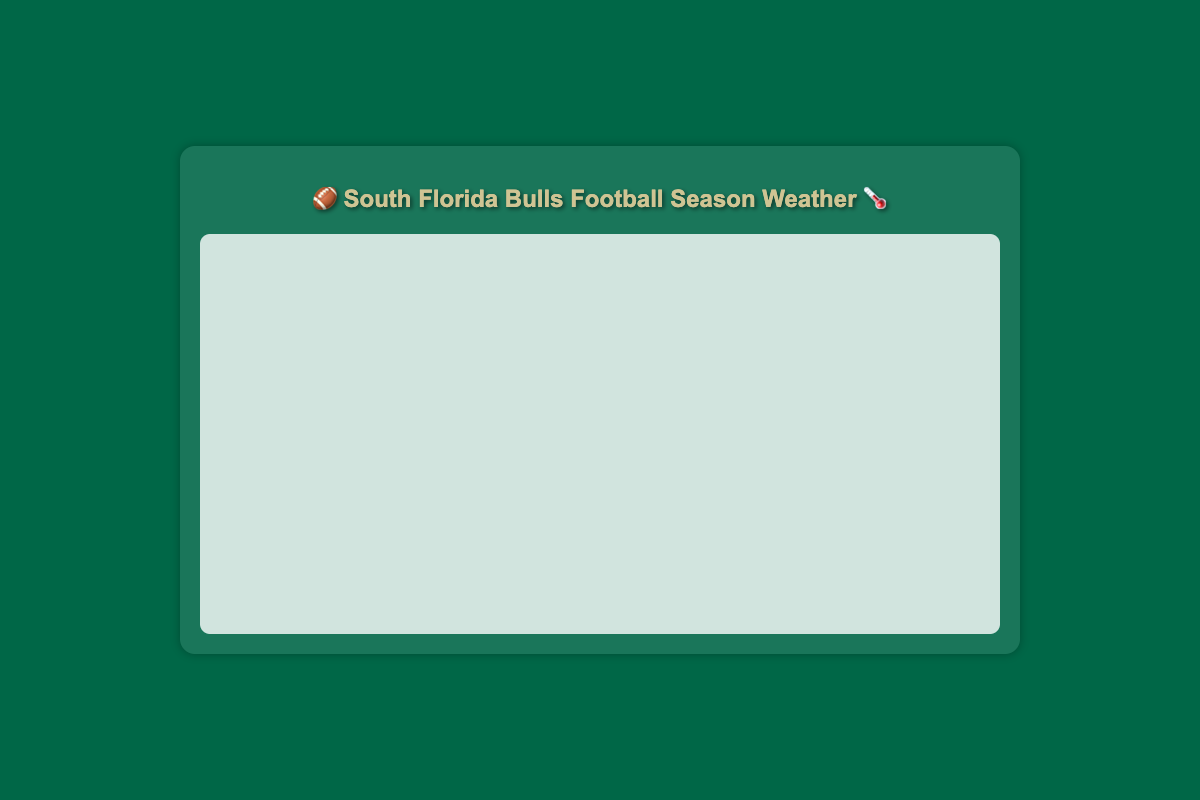What is the highest recorded temperature and on which date did it occur? The highest recorded temperature can be found by examining the "High Temperature" line on the chart and identifying the peak point. The corresponding date will be located on the x-axis vertically aligned with this peak.
Answer: 91°F on 2023-09-10 and 2023-09-24 How does the precipitation on September 10 compare to September 7? To compare the precipitation, check the "Precipitation (inches)" line on the relevant dates. September 10 shows a higher peak than September 7, indicating more precipitation.
Answer: Higher on September 10 What was the average high temperature from September 1 to September 10? To calculate this, sum the high temperatures from September 1 to September 10 and divide by the number of days. The sum is 88 + 89 + 87 + 90 + 89 + 88 + 87 + 86 + 89 + 91 = 884. The average is 884 / 10 = 88.4°F.
Answer: 88.4°F On which date was the humidity highest, and what was the value? The highest humidity value can be identified by finding the peak point on the "Humidity" line. The date corresponding to this peak is on the x-axis.
Answer: 88% on 2023-09-10 Which day had the lowest wind speed, and what was it? The lowest wind speed can be identified by finding the lowest point on the "Wind Speed" line. The corresponding date is on the x-axis.
Answer: 4 mph on 2023-09-06 and 2023-09-19 Calculate the difference in high temperature between September 5 and September 15. Look at the high temperature values on the two dates. For September 5, it's 89°F, and for September 15, it's 87°F. The difference is 89 - 87 = 2°F.
Answer: 2°F Which date experienced the highest amount of precipitation, and how much was it? Identify the peak of the "Precipitation (inches)" line and note the corresponding date on the x-axis.
Answer: 0.4 inches on 2023-09-10, 2023-09-17, and 2023-09-24 How does the low temperature trend from September 1 to September 30? Observe the "Low Temperature" line throughout the month. It starts relatively high, shows fluctuations but generally trends slightly downward towards the end.
Answer: Slightly downward trend What is the range of high temperatures observed in September? The range is determined by subtracting the minimum high temperature from the maximum high temperature. Minimum high temperature is 84°F and the maximum is 91°F. The range is 91 - 84 = 7°F.
Answer: 7°F Compare the precipitation on September 20 and September 30. Which day had more? Identify the precipitation values on these dates. September 20 has 0.1 inches and September 30 has 0.3 inches.
Answer: September 30 had more 